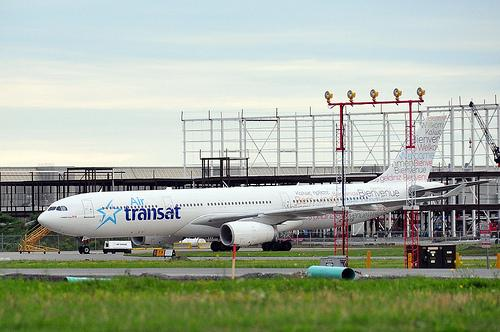Summarize the main scene captured in the image. The image primarily shows a white plane stationed on a landing lane at an airport. Mention the primary object in the image and state what it is doing. A white plane is parked on a landing lane at an airport. Elaborate on the principal component in the picture and its ongoing event. The primary component in the image is a white plane, which is currently parked on a landing lane. Explain the primary object of attention and its position in the photo. The focal point is a white plane, positioned on an airport landing lane. Illustrate the central theme of the image by mentioning the primary object and its activity. A white airplane stationed on a landing lane at an airport is the central theme of the image. Discuss the predominant feature of the image and its present status. The most noticeable object is a white plane, currently at rest on the landing lane. What is the most prominent entity in the picture, and what is its current situation? The picture's main focus is a white airplane, which is parked on a landing lane. Convey the essence of the image by mentioning the main subject and its situation. The image captures a white plane resting on an airport landing lane. Describe what the main highlight of the image is and what is taking place. A parked white plane on an airport landing lane makes the image's highlight. Provide a brief overview of the central subject in the photograph and its activity. The white airplane parked on a landing lane is the central subject of the photograph. 